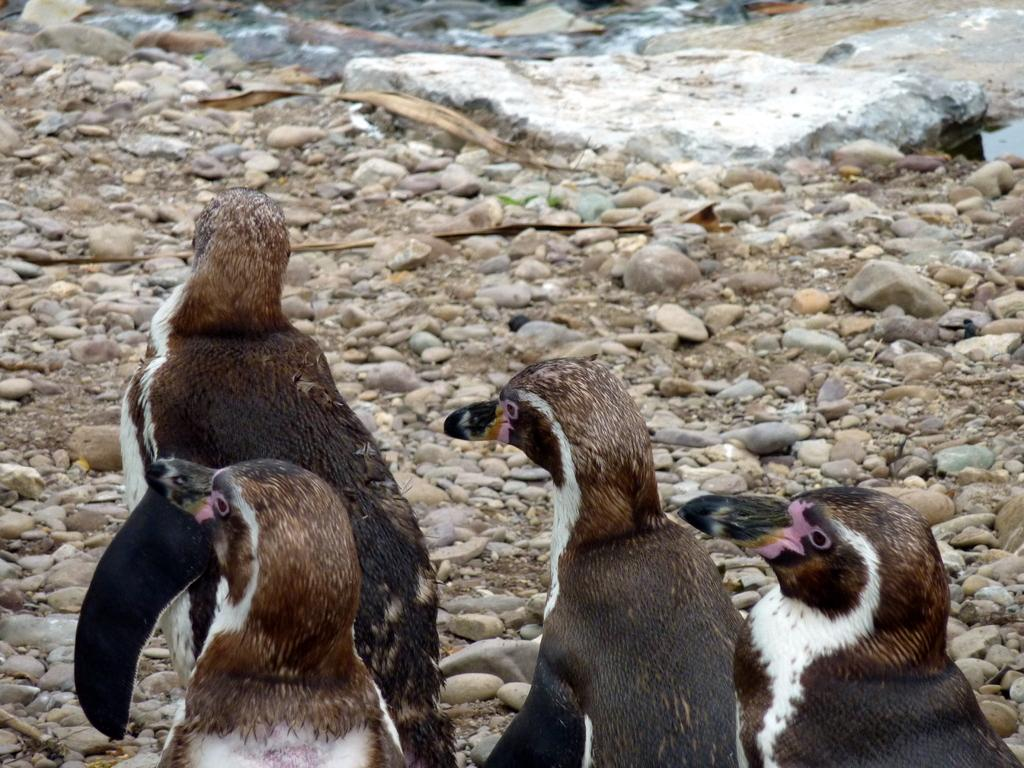What type of living organisms can be seen in the image? There are animals in the image. What color combination is used for the animals in the image? The animals are in black and white color combination. Where are the animals located in the image? The animals are on the ground. What can be found on the ground along with the animals? There are stones on the ground. What is visible in the background of the image? There is a rock and water in the background of the image. What type of paper is being used by the animals in the image? There is no paper present in the image; the animals are in black and white color combination and are on the ground. What type of lettuce can be seen growing near the animals in the image? There is no lettuce present in the image; the animals are on the ground, and the image features a rock and water in the background. 